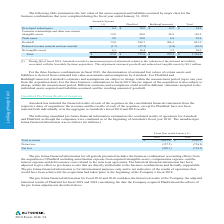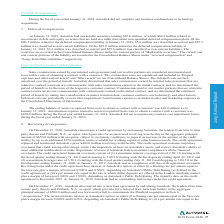According to Autodesk's financial document, What is the goodwill recorded primarily attributable to? Based on the financial document, the answer is The goodwill recorded is primarily attributable to synergies expected to arise after the acquisition. Also, How is the determination of estimated fair values of certain assets and liabilities for the three business combinations in fiscal 2019 derived? For the three business combinations in fiscal 2019, the determination of estimated fair values of certain assets and liabilities is derived from estimated fair value assessments and assumptions by Autodesk. The document states: "For the three business combinations in fiscal 2019, the determination of estimated fair values of certain assets and liabilities is derived from estim..." Also, What is the total amount of developed technologies? According to the financial document, $94.9 (in millions). The relevant text states: "Developed technologies $ 4.4 $ 78.0 $ 12.5 $ 94.9..." Also, can you calculate: What is the total amount of net tangible assets for PlanGrid and BuildingConnected? Based on the calculation: 18.4+3.5, the result is 21.9 (in millions). This is based on the information: "Net tangible assets 4.1 18.4 3.5 26.0 Net tangible assets 4.1 18.4 3.5 26.0..." The key data points involved are: 18.4, 3.5. Also, can you calculate: What is the total amount of developed technologies for Assemble Systems and Plan Grid? Based on the calculation: 4.4+78, the result is 82.4 (in millions). This is based on the information: "Developed technologies $ 4.4 $ 78.0 $ 12.5 $ 94.9 Developed technologies $ 4.4 $ 78.0 $ 12.5 $ 94.9..." The key data points involved are: 4.4, 78. Also, can you calculate: How much does goodwill account for the total? Based on the calculation: 867/1,124.4, the result is 77.11 (percentage). This is based on the information: "Total $ 93.6 $ 777.6 $ 253.2 $ 1,124.4 Goodwill 72.0 588.7 206.3 867.0..." The key data points involved are: 1,124.4, 867. 